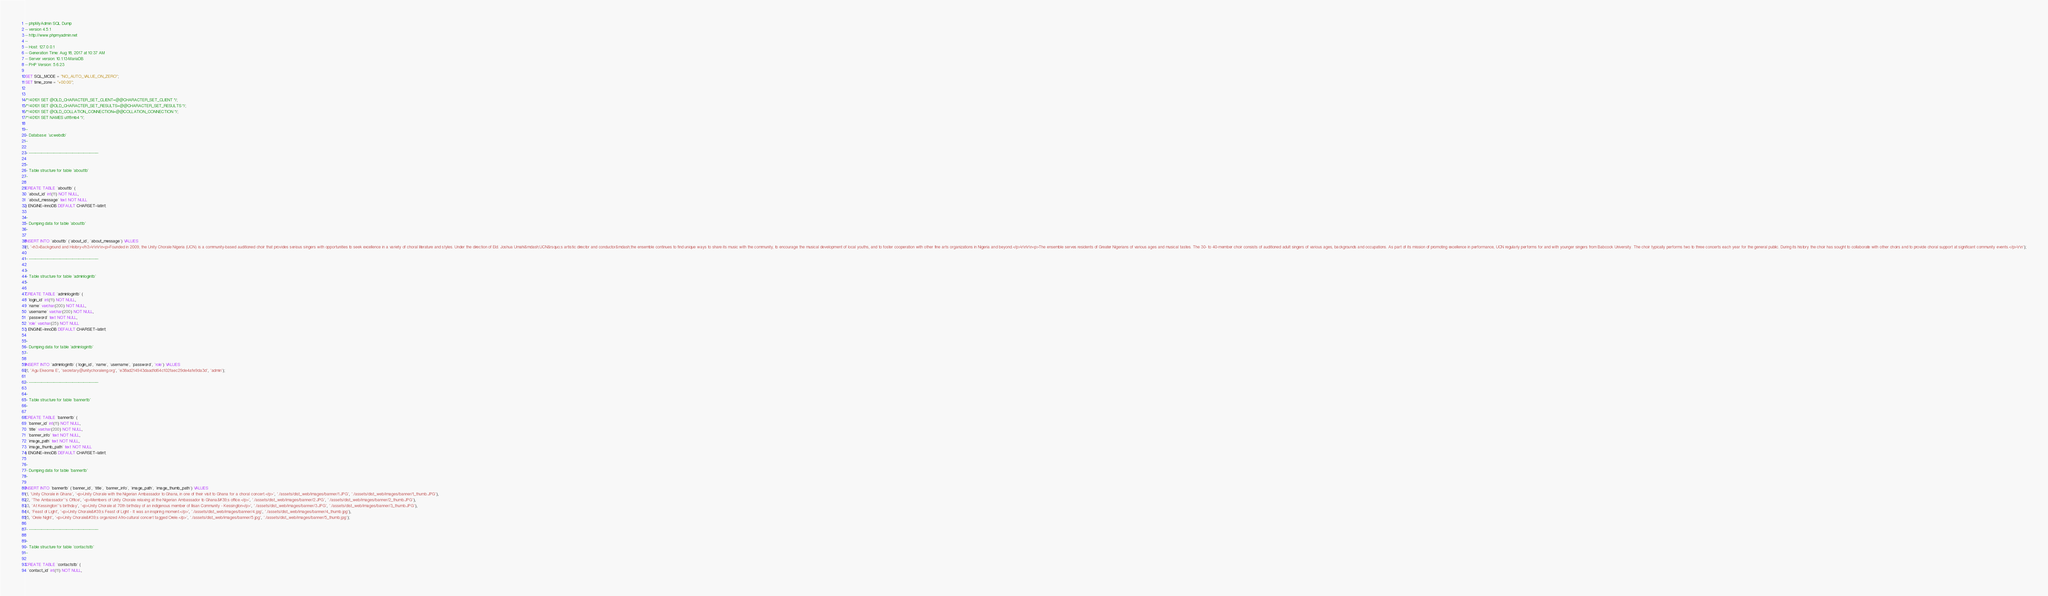Convert code to text. <code><loc_0><loc_0><loc_500><loc_500><_SQL_>-- phpMyAdmin SQL Dump
-- version 4.5.1
-- http://www.phpmyadmin.net
--
-- Host: 127.0.0.1
-- Generation Time: Aug 18, 2017 at 10:37 AM
-- Server version: 10.1.13-MariaDB
-- PHP Version: 5.6.23

SET SQL_MODE = "NO_AUTO_VALUE_ON_ZERO";
SET time_zone = "+00:00";


/*!40101 SET @OLD_CHARACTER_SET_CLIENT=@@CHARACTER_SET_CLIENT */;
/*!40101 SET @OLD_CHARACTER_SET_RESULTS=@@CHARACTER_SET_RESULTS */;
/*!40101 SET @OLD_COLLATION_CONNECTION=@@COLLATION_CONNECTION */;
/*!40101 SET NAMES utf8mb4 */;

--
-- Database: `ucwebdb`
--

-- --------------------------------------------------------

--
-- Table structure for table `abouttb`
--

CREATE TABLE `abouttb` (
  `about_id` int(11) NOT NULL,
  `about_message` text NOT NULL
) ENGINE=InnoDB DEFAULT CHARSET=latin1;

--
-- Dumping data for table `abouttb`
--

INSERT INTO `abouttb` (`about_id`, `about_message`) VALUES
(1, '<h3>Background and History</h3>\r\n\r\n<p>Founded in 2009, the Unity Chorale Nigeria (UCN) is a community-based auditioned choir that provides serious singers with opportunities to seek excellence in a variety of choral literature and styles. Under the direction of Eld. Joshua Umahi&mdash;UCN&rsquo;s artistic director and conductor&mdash;the ensemble continues to find unique ways to share its music with the community, to encourage the musical development of local youths, and to foster cooperation with other fine arts organizations in Nigeria and beyond.</p>\r\n\r\n<p>The ensemble serves residents of Greater Nigerians of various ages and musical tastes. The 30- to 40-member choir consists of auditioned adult singers of various ages, backgrounds and occupations. As part of its mission of promoting excellence in performance, UCN regularly performs for and with younger singers from Babcock University. The choir typically performs two to three concerts each year for the general public. During its history the choir has sought to collaborate with other choirs and to provide choral support at significant community events.</p>\r\n');

-- --------------------------------------------------------

--
-- Table structure for table `adminlogintb`
--

CREATE TABLE `adminlogintb` (
  `login_id` int(11) NOT NULL,
  `name` varchar(200) NOT NULL,
  `username` varchar(200) NOT NULL,
  `password` text NOT NULL,
  `role` varchar(25) NOT NULL
) ENGINE=InnoDB DEFAULT CHARSET=latin1;

--
-- Dumping data for table `adminlogintb`
--

INSERT INTO `adminlogintb` (`login_id`, `name`, `username`, `password`, `role`) VALUES
(1, 'Agu Ekeoma E', 'secretary@unitychoraleng.org', 'e38ad214943daad1d64c102faec29de4afe9da3d', 'admin');

-- --------------------------------------------------------

--
-- Table structure for table `bannertb`
--

CREATE TABLE `bannertb` (
  `banner_id` int(11) NOT NULL,
  `title` varchar(200) NOT NULL,
  `banner_info` text NOT NULL,
  `image_path` text NOT NULL,
  `image_thumb_path` text NOT NULL
) ENGINE=InnoDB DEFAULT CHARSET=latin1;

--
-- Dumping data for table `bannertb`
--

INSERT INTO `bannertb` (`banner_id`, `title`, `banner_info`, `image_path`, `image_thumb_path`) VALUES
(1, 'Unity Chorale in Ghana', '<p>Unity Chorale with the Nigerian Ambassador to Ghana, in one of their visit to Ghana for a choral concert.</p>', './assets/dist_web/images/banner/1.JPG', './assets/dist_web/images/banner/1_thumb.JPG'),
(2, 'The Ambassador''s Office', '<p>Members of Unity Chorale relaxing at the Nigerian Ambassador to Ghana&#39;s office.</p>', './assets/dist_web/images/banner/2.JPG', './assets/dist_web/images/banner/2_thumb.JPG'),
(3, 'At Kessington''s birthday', '<p>Unity Chorale at 70th birthday of an indigenous member of Ilisan Community - Kessington</p>', './assets/dist_web/images/banner/3.JPG', './assets/dist_web/images/banner/3_thumb.JPG'),
(4, 'Feast of Light', '<p>Unity Chorale&#39;s Feast of Light - It was an inspiring moment.</p>', './assets/dist_web/images/banner/4.jpg', './assets/dist_web/images/banner/4_thumb.jpg'),
(5, 'Orele Night', '<p>Unity Chorale&#39;s organized Afro-cultural concert tagged Orele.</p>', './assets/dist_web/images/banner/5.jpg', './assets/dist_web/images/banner/5_thumb.jpg');

-- --------------------------------------------------------

--
-- Table structure for table `contactstb`
--

CREATE TABLE `contactstb` (
  `contact_id` int(11) NOT NULL,</code> 